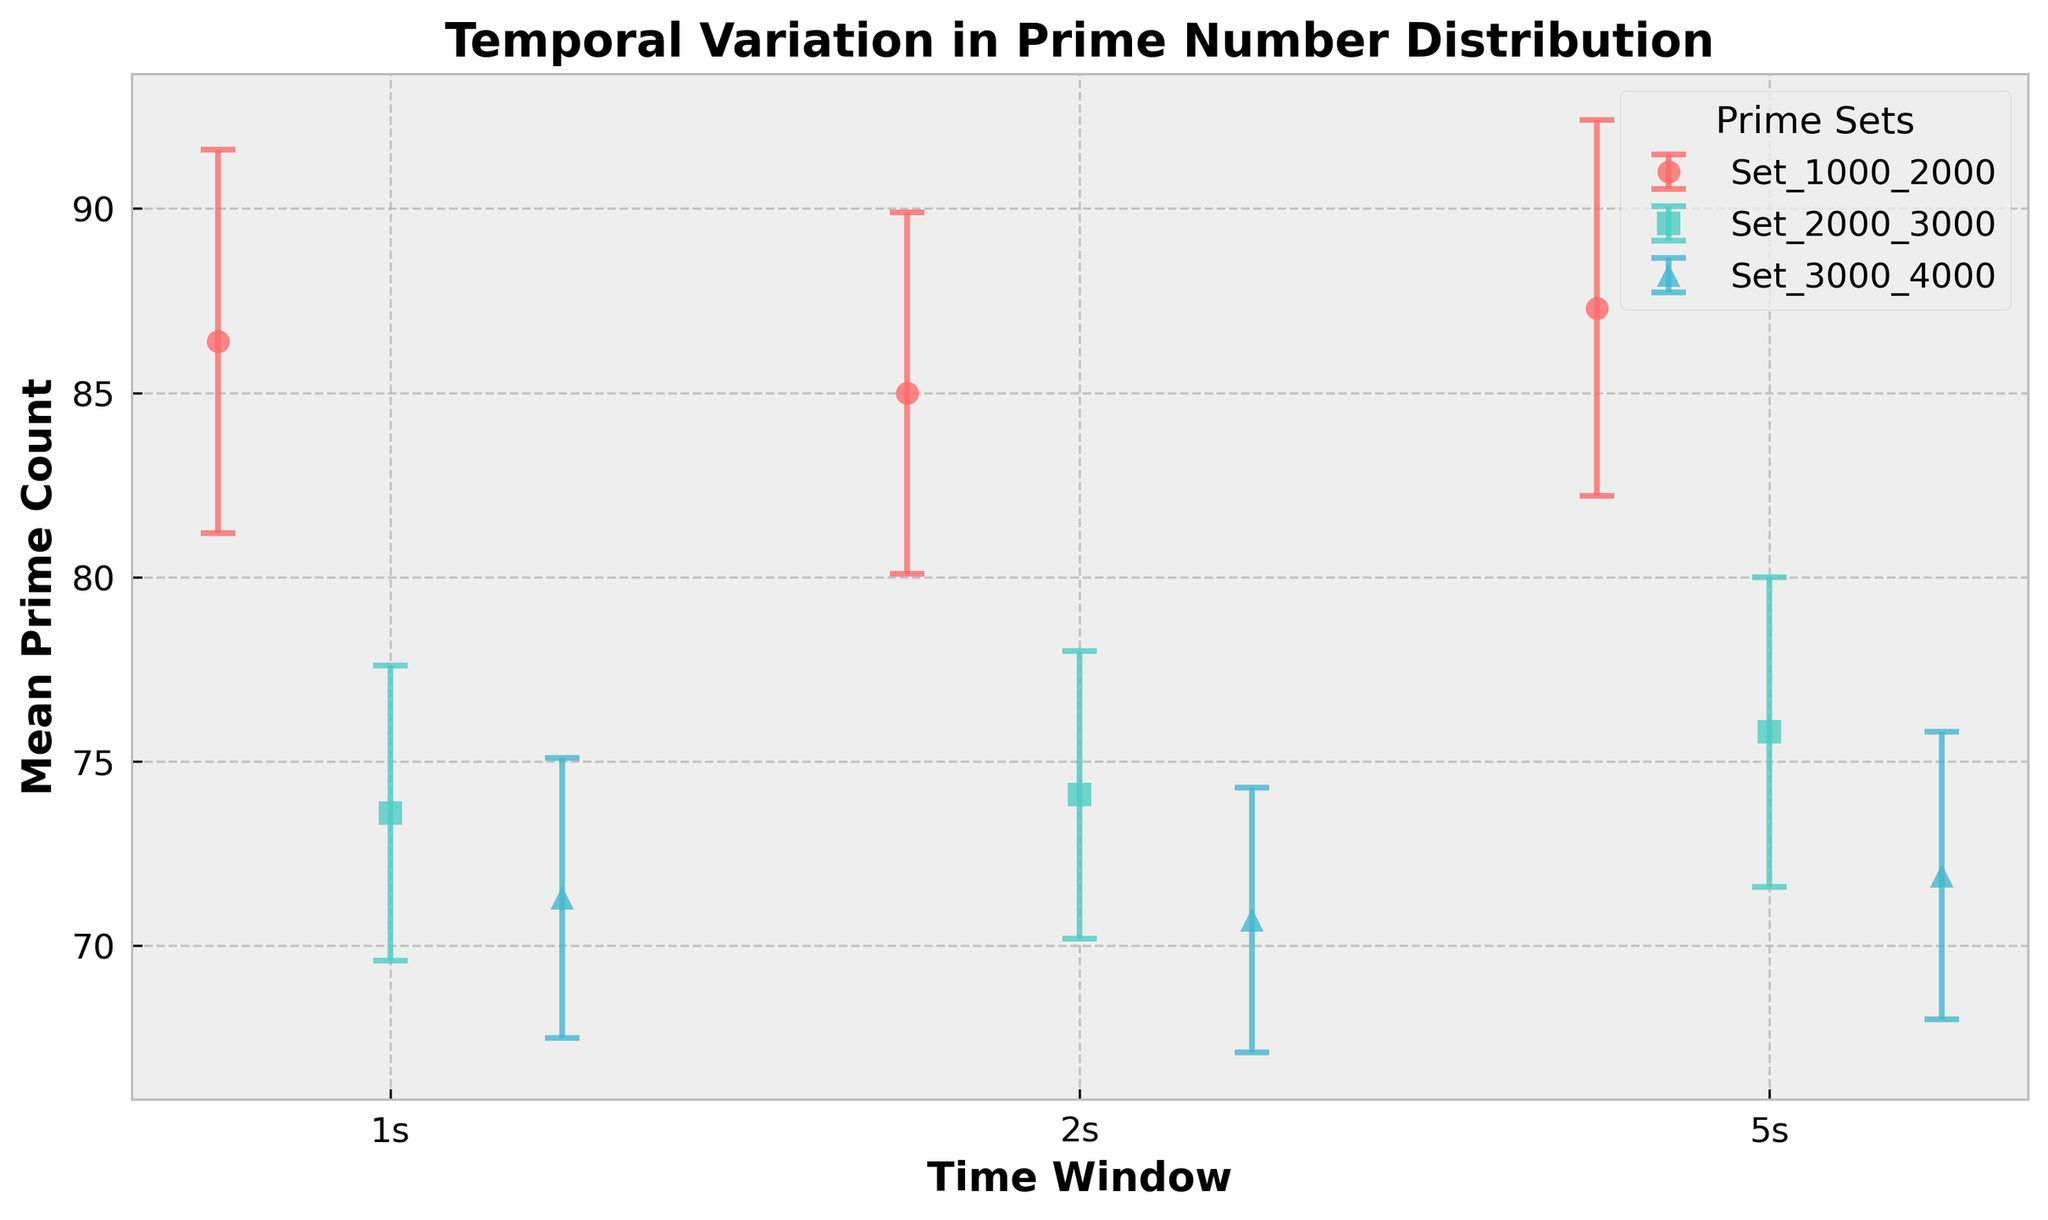What is the title of the figure? The title of the figure is placed at the top of the plot and can be read directly from the figure.
Answer: Temporal Variation in Prime Number Distribution What is the mean prime count for the Set_3000_4000 during the 1-second time window? Locate the point corresponding to Set_3000_4000 and 1s time window and refer to its y-axis value.
Answer: 71.3 Which prime set has the highest mean prime count in the 2-second time window? Compare the mean prime counts for all prime sets in the 2s time window. Set_1000_2000 has a higher mean value than other sets.
Answer: Set_1000_2000 What is the average of the mean prime counts for Set_2000_3000 across all time windows? Calculate the sum of mean prime counts for Set_2000_3000 (73.6 + 74.1 + 75.8) and then divide by the number of time windows (3).
Answer: 74.5 Which prime set shows the least variation in prime count across different time windows? Compare the range of error bars for each prime set. Set_3000_4000 has smallest error ranges indicating the least variation.
Answer: Set_3000_4000 How does the mean prime count of Set_2000_3000 in the 5-second window compare to the 1-second window? Compare the mean prime counts of Set_2000_3000 at 5s (75.8) and 1s (73.6) by subtracting 73.6 from 75.8.
Answer: Higher by 2.2 What is the mean prime count difference between Set_1000_2000 and Set_3000_4000 in the 5-second window? Subtract the mean prime count of Set_3000_4000 at 5s (71.9) from the mean prime count of Set_1000_2000 at 5s (87.3).
Answer: 15.4 Which prime set exhibits the highest error margin in any time window, and in which time window does it occur? Compare the error bar lengths for all data points. Set_1000_2000 has the highest error margin of 5.2 in the 1s window.
Answer: Set_1000_2000 in 1s Is the mean prime count for all sets relatively stable or does it fluctuate significantly with increasing time windows? Observe the trend in the mean prime counts across different time windows. The values are stable as they do not show significant fluctuations.
Answer: Stable 